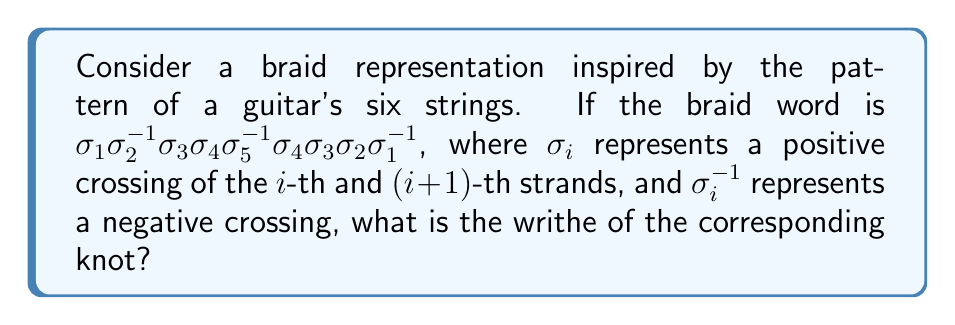Provide a solution to this math problem. Let's approach this step-by-step:

1) First, recall that the writhe of a knot is the sum of the signs of all crossings in any diagram of the knot. In a braid representation:
   - $\sigma_i$ contributes +1 to the writhe
   - $\sigma_i^{-1}$ contributes -1 to the writhe

2) Let's count the contributions from each term in the braid word:

   $\sigma_1$: +1
   $\sigma_2^{-1}$: -1
   $\sigma_3$: +1
   $\sigma_4$: +1
   $\sigma_5^{-1}$: -1
   $\sigma_4$: +1
   $\sigma_3$: +1
   $\sigma_2$: +1
   $\sigma_1^{-1}$: -1

3) Now, let's sum up all these contributions:

   $(+1) + (-1) + (+1) + (+1) + (-1) + (+1) + (+1) + (+1) + (-1) = 3$

Therefore, the writhe of the knot represented by this braid is 3.

This analysis mirrors how an AI algorithm might process string patterns, converting them into numerical representations - a concept that might resonate with a software engineer working on AI advancements.
Answer: 3 